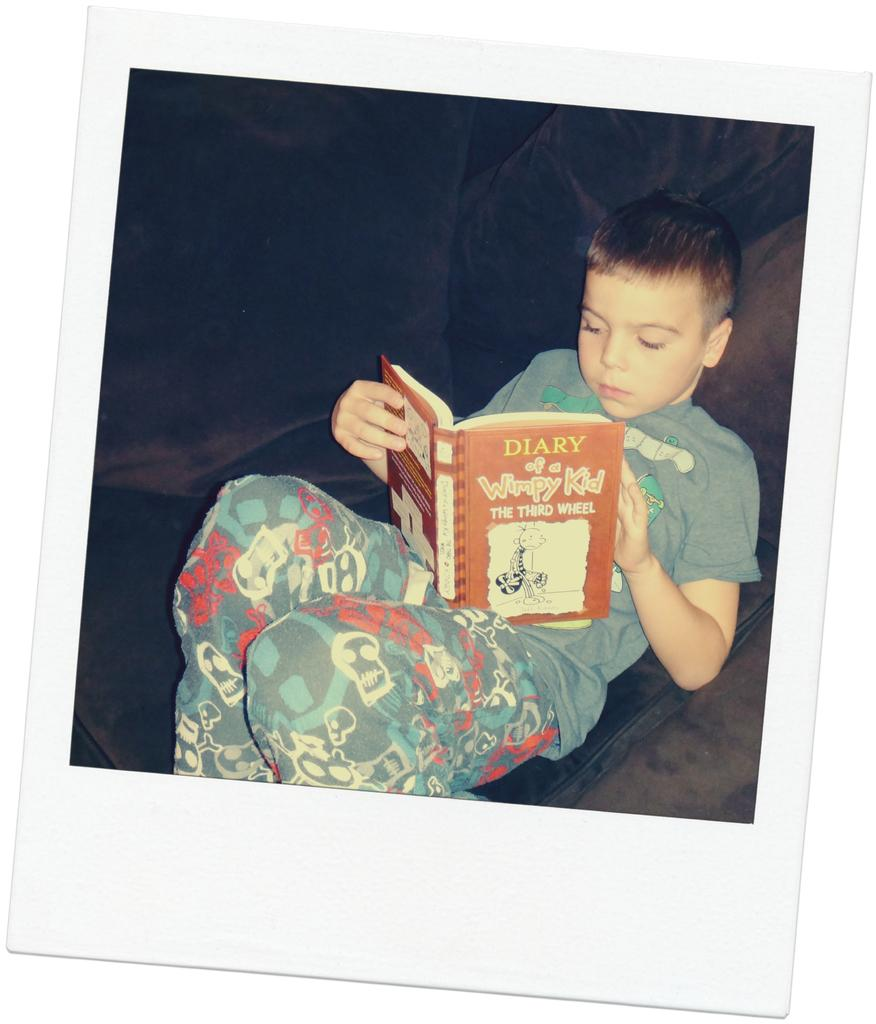Provide a one-sentence caption for the provided image. A young boy reads "Diary of a Wimpy Kid - The Third Wheel.". 